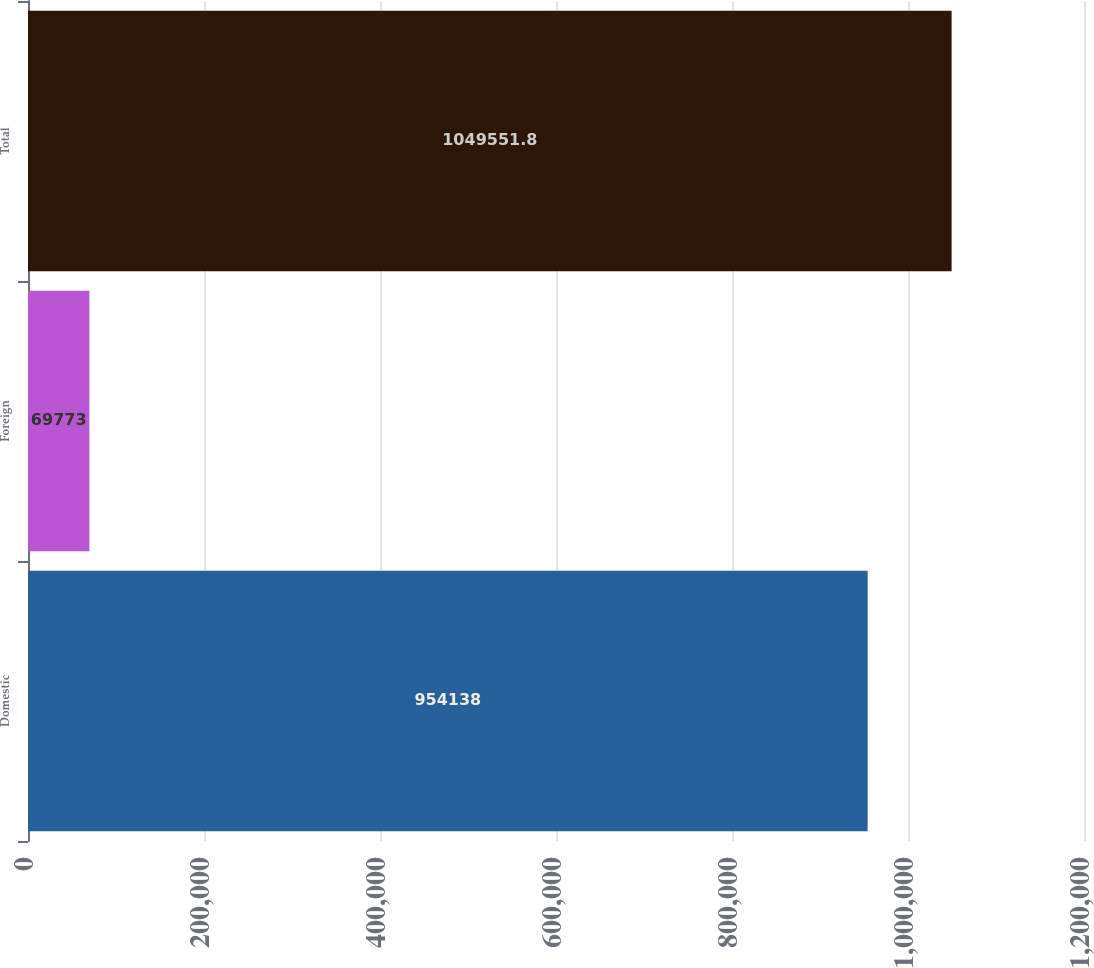Convert chart. <chart><loc_0><loc_0><loc_500><loc_500><bar_chart><fcel>Domestic<fcel>Foreign<fcel>Total<nl><fcel>954138<fcel>69773<fcel>1.04955e+06<nl></chart> 